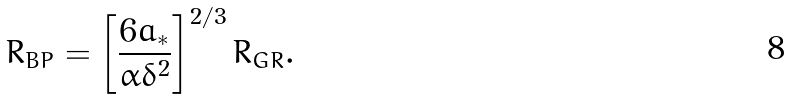<formula> <loc_0><loc_0><loc_500><loc_500>R _ { B P } = \left [ \frac { 6 a _ { * } } { \alpha \delta ^ { 2 } } \right ] ^ { 2 / 3 } R _ { G R } .</formula> 